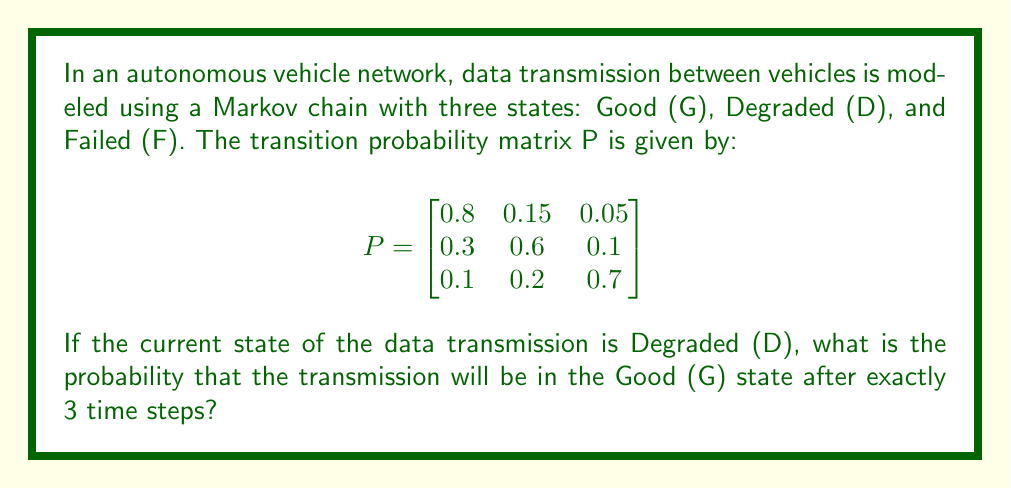Teach me how to tackle this problem. To solve this problem, we need to use the Chapman-Kolmogorov equations and calculate the 3-step transition probability from state D to state G.

Step 1: Identify the initial state vector.
Since we start in the Degraded (D) state, our initial state vector is:
$$v_0 = \begin{bmatrix} 0 & 1 & 0 \end{bmatrix}$$

Step 2: Calculate $P^3$ (the transition matrix after 3 steps).
$P^3 = P \times P \times P$

We can use matrix multiplication to compute this:

$$P^3 = \begin{bmatrix}
0.677 & 0.2205 & 0.1025 \\
0.523 & 0.3255 & 0.1515 \\
0.271 & 0.3015 & 0.4275
\end{bmatrix}$$

Step 3: Multiply the initial state vector by $P^3$.
$$v_3 = v_0 \times P^3 = \begin{bmatrix} 0 & 1 & 0 \end{bmatrix} \times \begin{bmatrix}
0.677 & 0.2205 & 0.1025 \\
0.523 & 0.3255 & 0.1515 \\
0.271 & 0.3015 & 0.4275
\end{bmatrix}$$

$$v_3 = \begin{bmatrix} 0.523 & 0.3255 & 0.1515 \end{bmatrix}$$

Step 4: Extract the probability of being in the Good (G) state after 3 steps.
This is the first element of the resulting vector $v_3$, which is 0.523.

Therefore, the probability that the transmission will be in the Good (G) state after exactly 3 time steps, given that it started in the Degraded (D) state, is 0.523 or 52.3%.
Answer: 0.523 